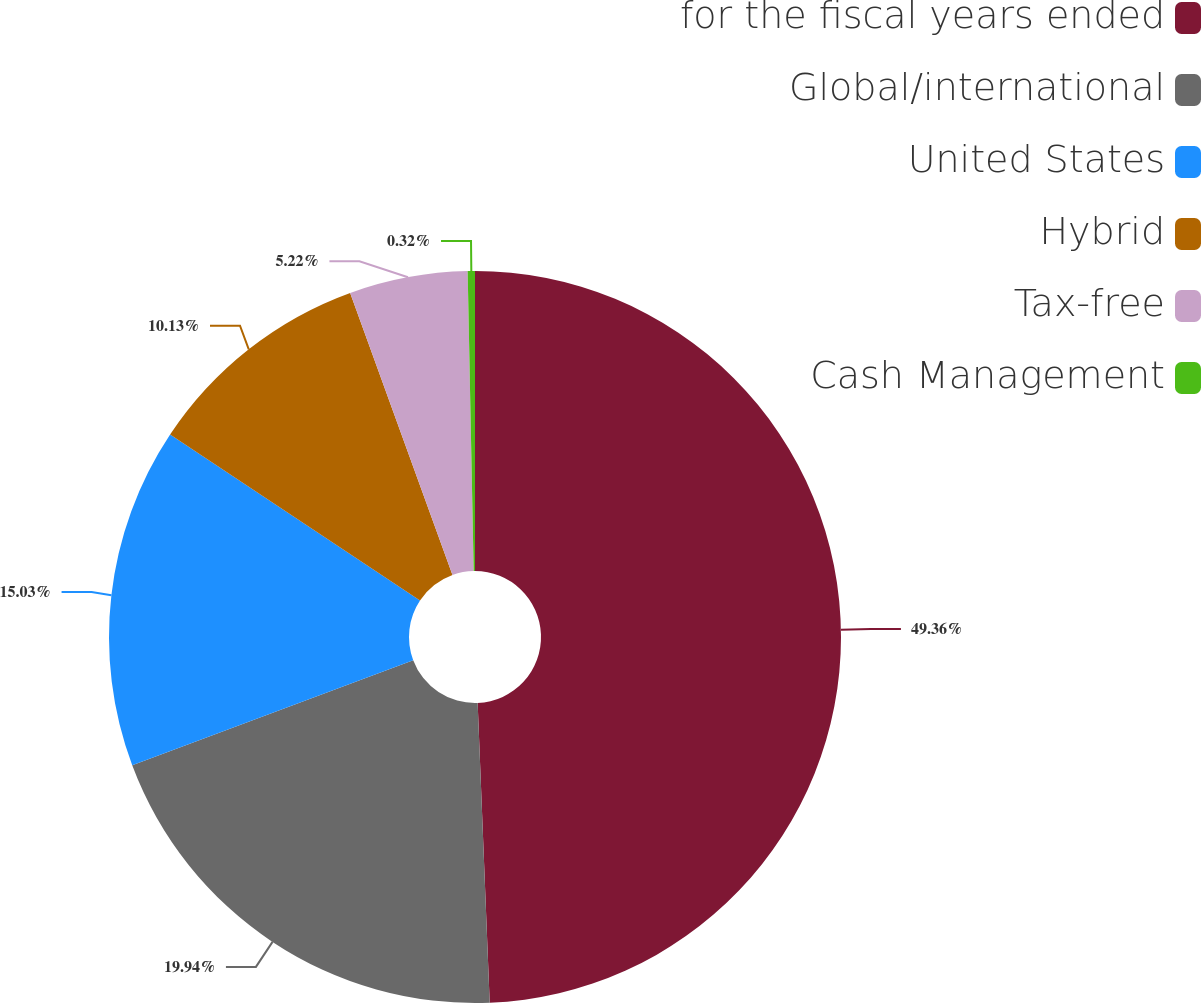Convert chart to OTSL. <chart><loc_0><loc_0><loc_500><loc_500><pie_chart><fcel>for the fiscal years ended<fcel>Global/international<fcel>United States<fcel>Hybrid<fcel>Tax-free<fcel>Cash Management<nl><fcel>49.36%<fcel>19.94%<fcel>15.03%<fcel>10.13%<fcel>5.22%<fcel>0.32%<nl></chart> 